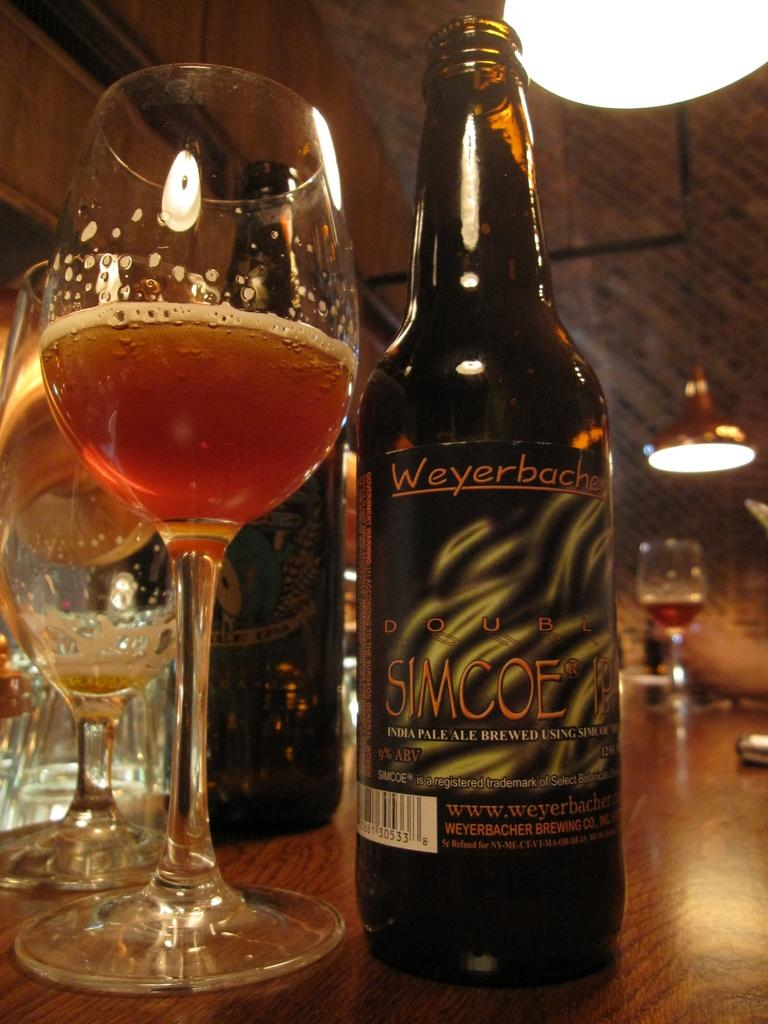What type of beverage containers are present in the image? There are wine bottles in the image. What type of drinking vessels are present in the image? There are wine glasses in the image. Where are the wine bottles and glasses located? The wine bottles and glasses are on a table. What can be seen in the background of the image? There are lights visible in the background of the image. How much sleet is present on the table in the image? There is no sleet present in the image; it features wine bottles and glasses on a table with lights in the background. 